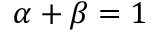Convert formula to latex. <formula><loc_0><loc_0><loc_500><loc_500>\alpha + \beta = 1</formula> 